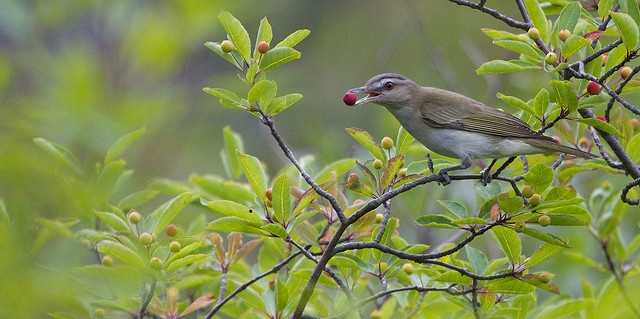Describe the objects in this image and their specific colors. I can see a bird in gray, darkgray, black, and darkgreen tones in this image. 